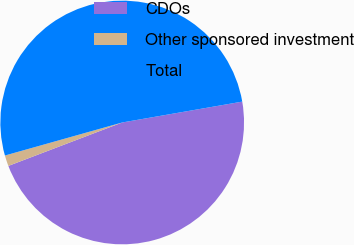<chart> <loc_0><loc_0><loc_500><loc_500><pie_chart><fcel>CDOs<fcel>Other sponsored investment<fcel>Total<nl><fcel>46.94%<fcel>1.43%<fcel>51.63%<nl></chart> 